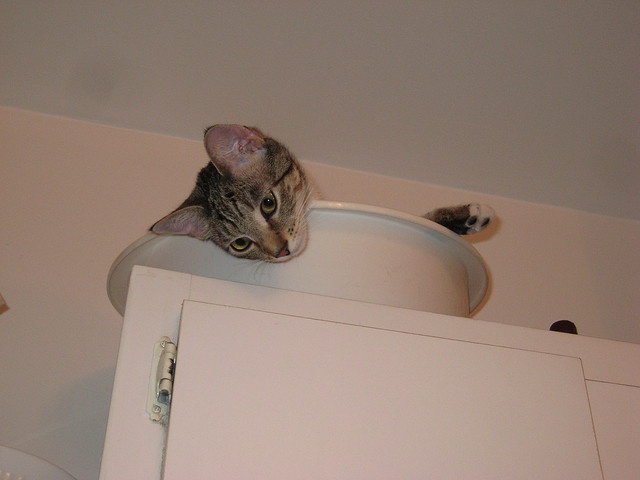Describe the objects in this image and their specific colors. I can see bowl in gray and darkgray tones and cat in gray, black, and maroon tones in this image. 